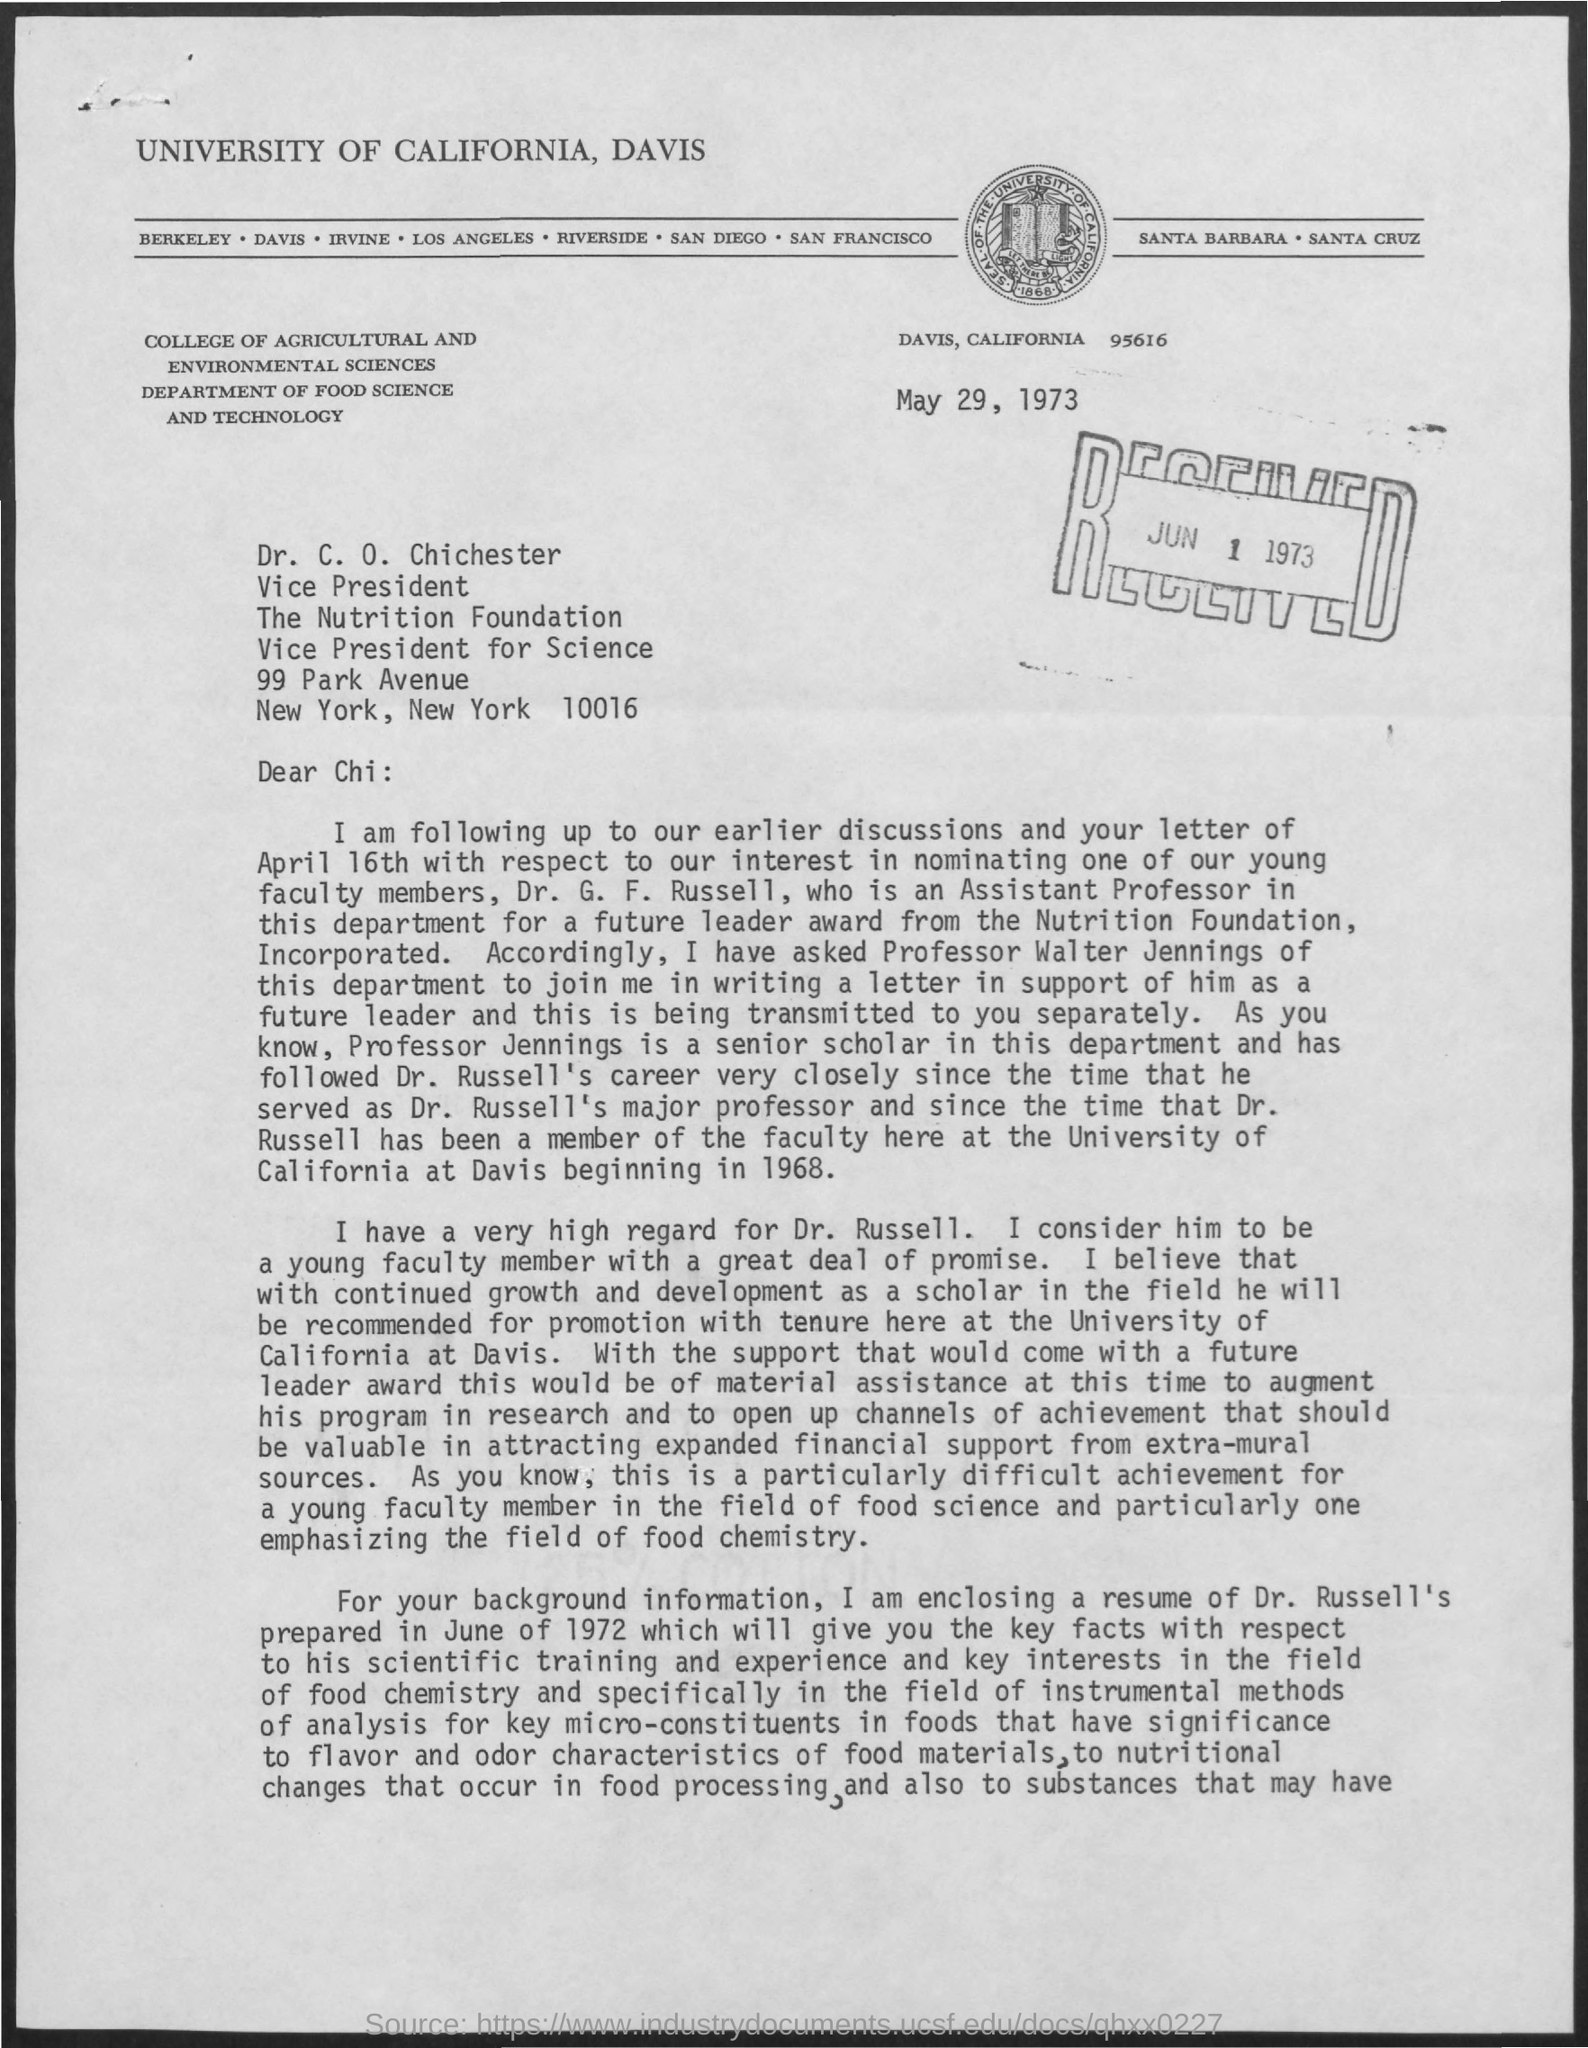On which date this letter was received ?
Ensure brevity in your answer.  Jun 1 1973. What is the college mentioned in the given letter ?
Provide a short and direct response. College of agricultural and environmental sciences. On which date this letter was written ?
Ensure brevity in your answer.  May 29, 1973. 